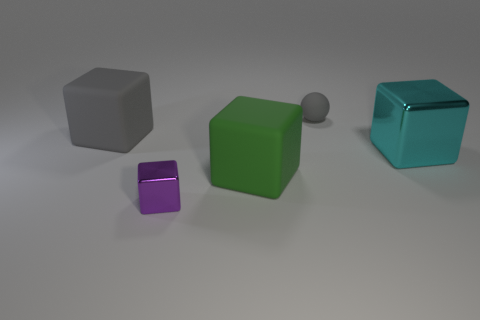Are there any small purple metallic cubes to the left of the green rubber block?
Your answer should be very brief. Yes. There is a rubber cube to the right of the tiny thing left of the tiny gray matte sphere; are there any rubber blocks that are to the left of it?
Ensure brevity in your answer.  Yes. There is a gray thing that is behind the big gray rubber thing; is it the same shape as the purple metallic object?
Offer a very short reply. No. There is a big cube that is made of the same material as the purple thing; what is its color?
Offer a terse response. Cyan. How many small gray objects are made of the same material as the tiny gray sphere?
Provide a succinct answer. 0. There is a large thing that is to the right of the rubber thing on the right side of the big matte thing that is on the right side of the big gray object; what is its color?
Your response must be concise. Cyan. Is the size of the purple metal thing the same as the sphere?
Ensure brevity in your answer.  Yes. Are there any other things that have the same shape as the big shiny thing?
Offer a terse response. Yes. How many objects are big blocks behind the cyan metallic block or metal cubes?
Your answer should be very brief. 3. Is the shape of the large green object the same as the cyan object?
Your response must be concise. Yes. 